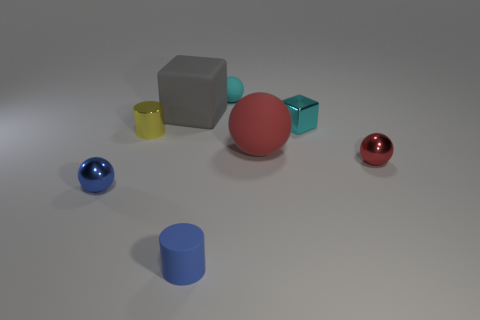What number of cyan balls have the same size as the metal cube?
Your answer should be very brief. 1. The cyan rubber sphere is what size?
Your answer should be compact. Small. What number of rubber things are in front of the cyan metal cube?
Your answer should be very brief. 2. The small red thing that is the same material as the cyan block is what shape?
Ensure brevity in your answer.  Sphere. Are there fewer tiny rubber spheres that are to the left of the cyan matte sphere than cubes behind the small shiny cube?
Your answer should be compact. Yes. Is the number of large purple rubber cubes greater than the number of metallic cubes?
Provide a succinct answer. No. What is the material of the big gray block?
Your answer should be very brief. Rubber. The tiny rubber object behind the metal block is what color?
Your answer should be very brief. Cyan. Is the number of large red rubber objects in front of the cyan rubber ball greater than the number of gray cubes that are right of the red metallic ball?
Offer a very short reply. Yes. There is a shiny ball on the right side of the cube to the right of the cylinder in front of the small yellow shiny object; what is its size?
Provide a short and direct response. Small. 